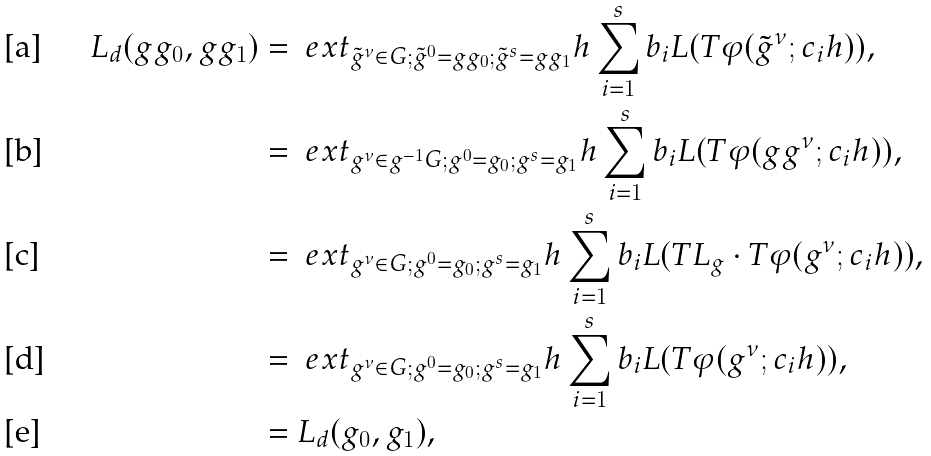<formula> <loc_0><loc_0><loc_500><loc_500>L _ { d } ( g g _ { 0 } , g g _ { 1 } ) & = \ e x t _ { \tilde { g } ^ { \nu } \in G ; \tilde { g } ^ { 0 } = g g _ { 0 } ; \tilde { g } ^ { s } = g g _ { 1 } } h \sum _ { i = 1 } ^ { s } b _ { i } L ( T \varphi ( \tilde { g } ^ { \nu } ; c _ { i } h ) ) , \\ & = \ e x t _ { g ^ { \nu } \in g ^ { - 1 } G ; g ^ { 0 } = g _ { 0 } ; g ^ { s } = g _ { 1 } } h \sum _ { i = 1 } ^ { s } b _ { i } L ( T \varphi ( g g ^ { \nu } ; c _ { i } h ) ) , \\ & = \ e x t _ { g ^ { \nu } \in G ; g ^ { 0 } = g _ { 0 } ; g ^ { s } = g _ { 1 } } h \sum _ { i = 1 } ^ { s } b _ { i } L ( T L _ { g } \cdot T \varphi ( g ^ { \nu } ; c _ { i } h ) ) , \\ & = \ e x t _ { g ^ { \nu } \in G ; g ^ { 0 } = g _ { 0 } ; g ^ { s } = g _ { 1 } } h \sum _ { i = 1 } ^ { s } b _ { i } L ( T \varphi ( g ^ { \nu } ; c _ { i } h ) ) , \\ & = L _ { d } ( g _ { 0 } , g _ { 1 } ) ,</formula> 